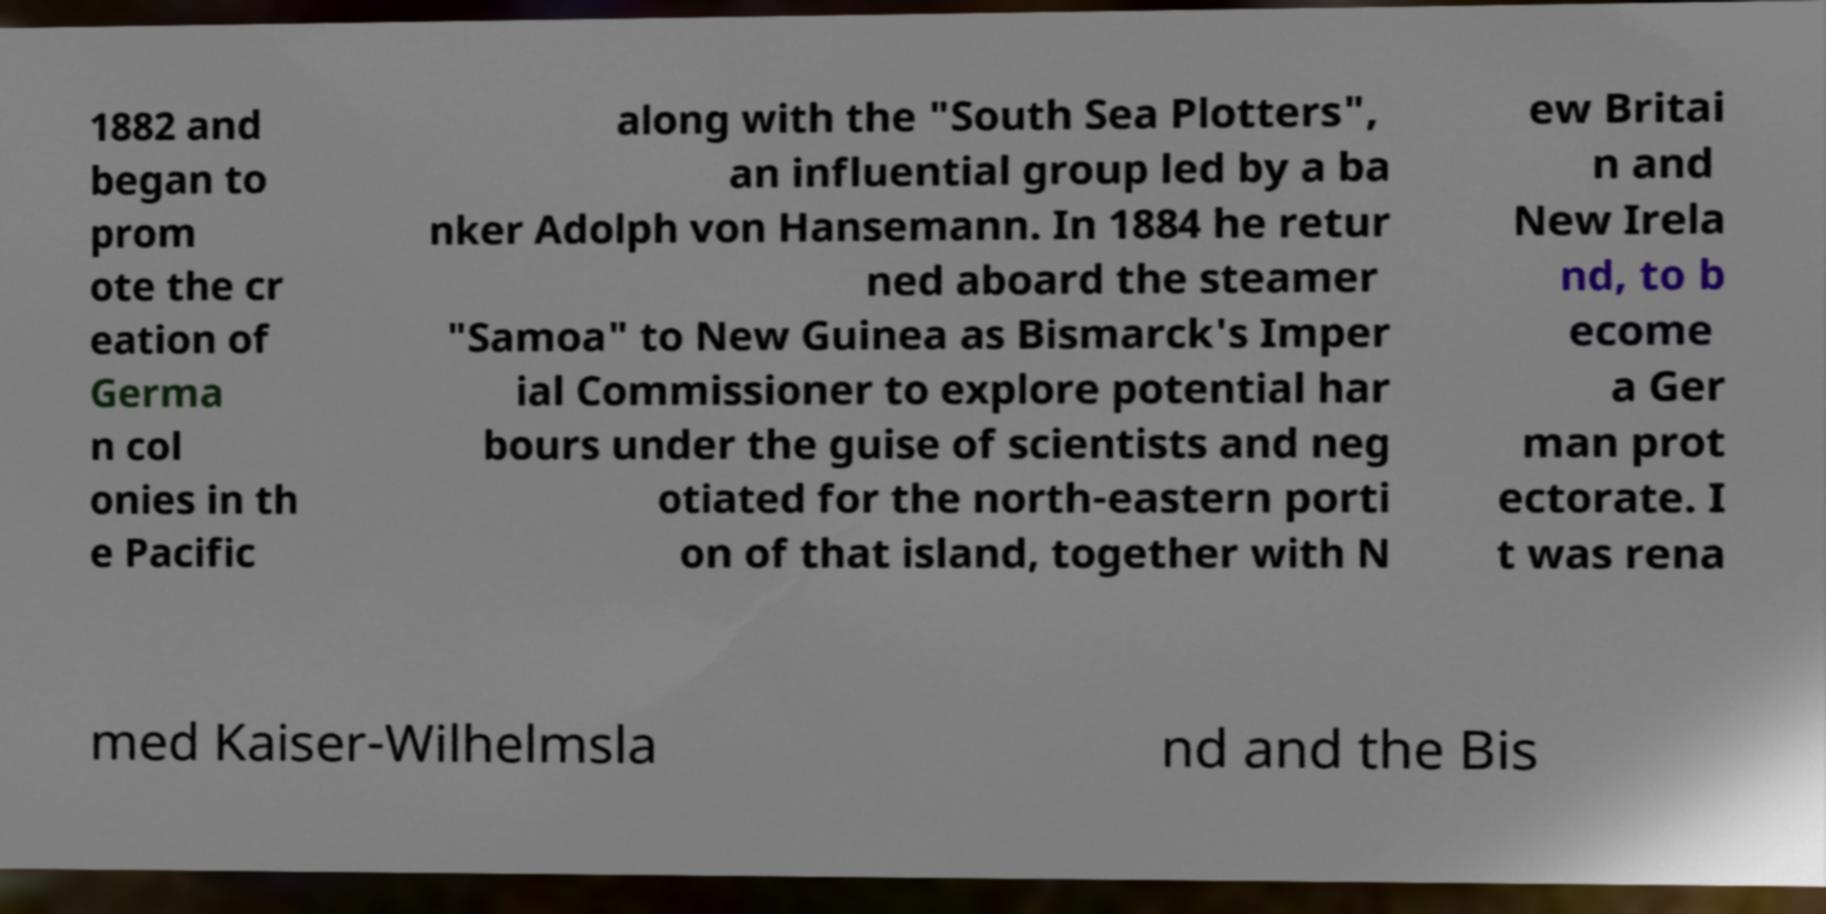Could you assist in decoding the text presented in this image and type it out clearly? 1882 and began to prom ote the cr eation of Germa n col onies in th e Pacific along with the "South Sea Plotters", an influential group led by a ba nker Adolph von Hansemann. In 1884 he retur ned aboard the steamer "Samoa" to New Guinea as Bismarck's Imper ial Commissioner to explore potential har bours under the guise of scientists and neg otiated for the north-eastern porti on of that island, together with N ew Britai n and New Irela nd, to b ecome a Ger man prot ectorate. I t was rena med Kaiser-Wilhelmsla nd and the Bis 